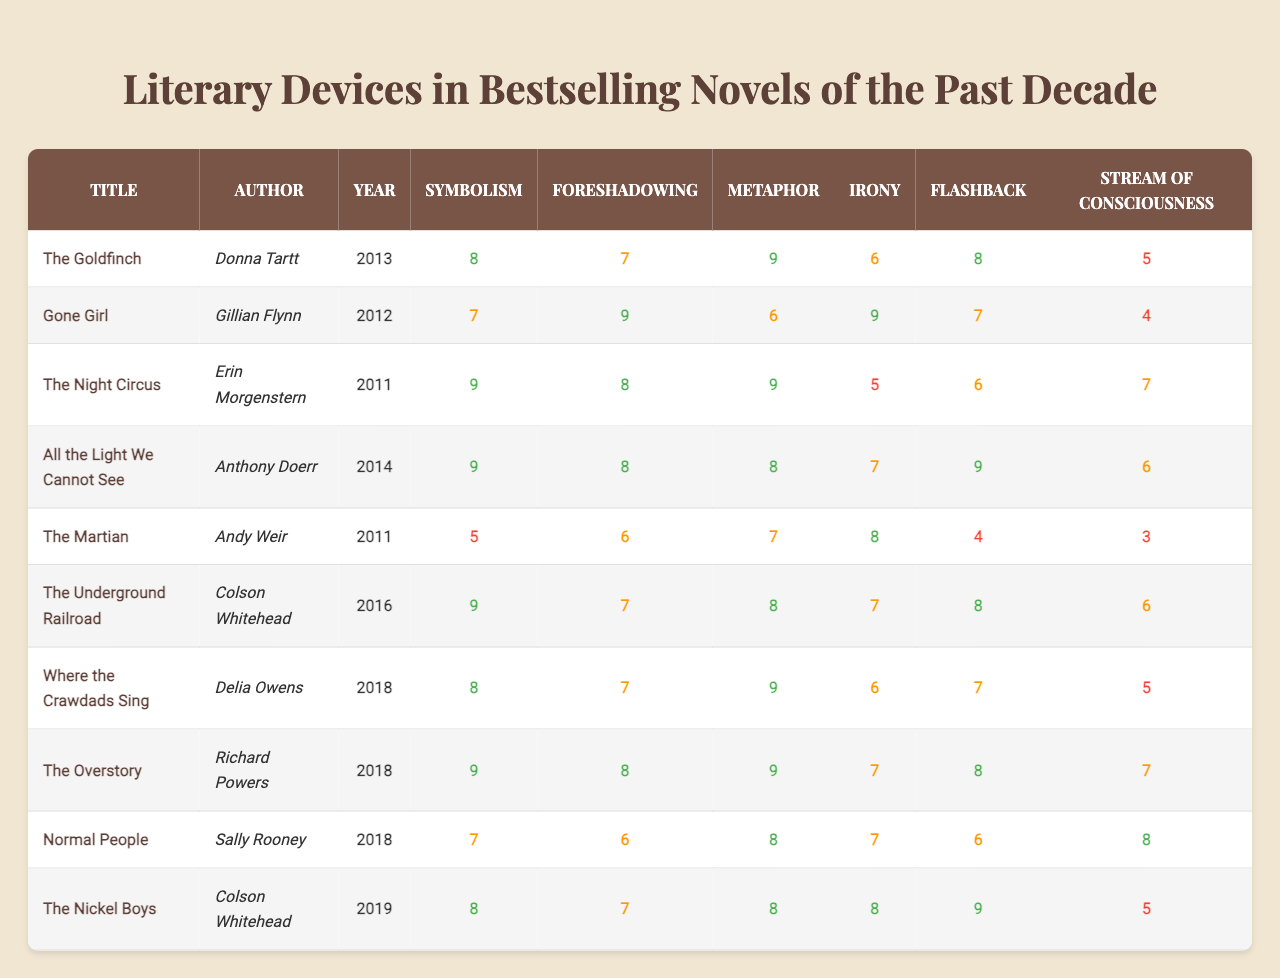What is the highest rating for metaphor among the listed novels? The highest rating for metaphor is 9, which appears for "The Goldfinch," "The Night Circus," "All the Light We Cannot See," "The Overstory," and "Where the Crawdads Sing." I checked the ratings for each novel in the metaphor column and noted that 9 is the maximum value.
Answer: 9 Which novel has the lowest rating for stream of consciousness? The novel with the lowest rating for stream of consciousness is "The Martian," which has a rating of 3. I examined the stream of consciousness ratings and found that 3 is the minimum score.
Answer: The Martian What is the average rating for symbolism across all novels? To find the average rating for symbolism, I summed the symbolism ratings (8 + 7 + 9 + 9 + 5 + 9 + 8 + 9 + 7 + 8 = 81) and divided by the number of novels (10). Thus, the average is 81/10 = 8.1.
Answer: 8.1 Which author has both a novel with the highest symbolism and a novel with the highest irony rating? Colson Whitehead is the author with "The Underground Railroad," which has the highest symbolism rating of 9, and "The Nickel Boys," which has an irony rating of 8. I looked at the ratings for both symbolism and irony, identifying the highest for each column, confirming both novels are by the same author.
Answer: Colson Whitehead Is "Gone Girl" higher in foreshadowing than "Normal People"? Yes, "Gone Girl" has a foreshadowing rating of 9 while "Normal People" has a rating of 6. I compared the foreshadowing ratings for both novels and confirmed one is greater than the other.
Answer: Yes What is the difference between the highest and lowest ratings for flashback? The highest rating for flashback is 9 (from "All the Light We Cannot See" and "The Nickel Boys"), and the lowest is 4 (from "The Martian"). The difference is 9 - 4 = 5. I confirmed the flashback ratings for both extremes and calculated the difference.
Answer: 5 Which novel has the best combination of foreshadowing and metaphor ratings? "Gone Girl" combines a foreshadowing rating of 9 with a metaphor rating of 6, resulting in the highest combination of ratings (9+6=15) among the listed novels. I compared the sums of foreshadowing and metaphor ratings for each novel to determine which had the highest total.
Answer: Gone Girl Are there any novels that have a rating of 8 for both symbolism and foreshadowing? Yes, "All the Light We Cannot See," "The Underground Railroad," and "The Overstory" all have a rating of 8 for both symbolism and foreshadowing. I checked the corresponding columns for each novel and confirmed their scores.
Answer: Yes 